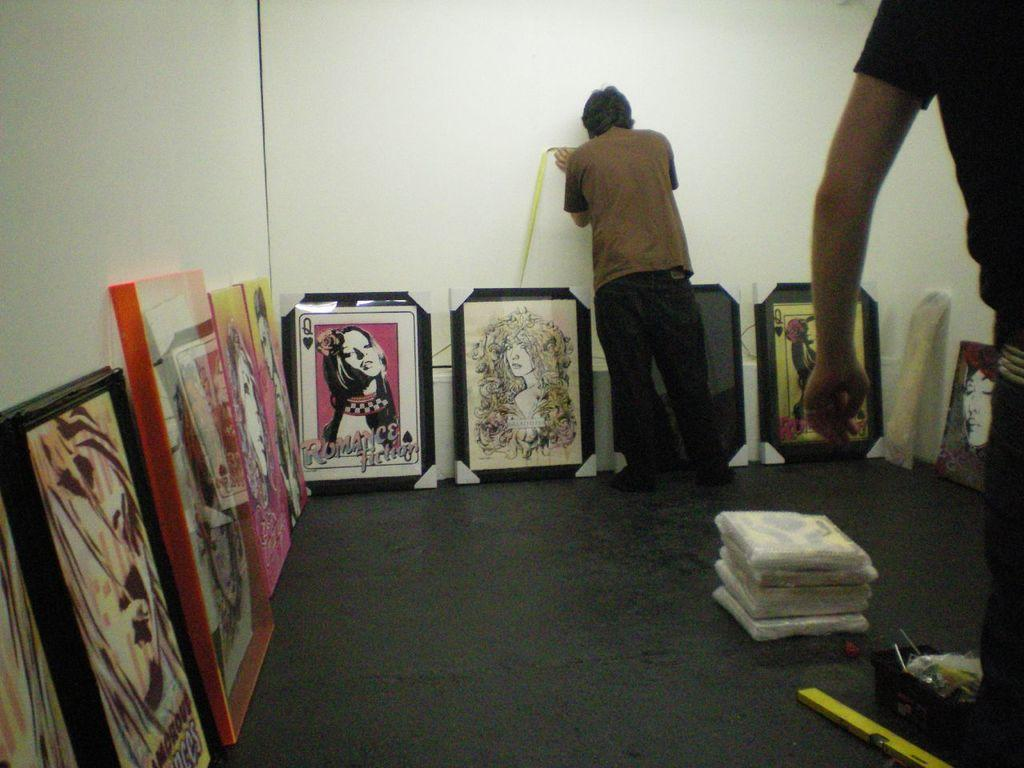<image>
Create a compact narrative representing the image presented. Two men are working around paintings on the floor one of which says "romance" on the bottom in pink letters. 